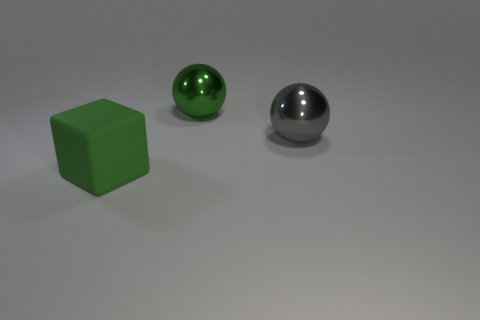There is a green object behind the green rubber object; does it have the same size as the green thing on the left side of the green sphere?
Give a very brief answer. Yes. What number of yellow things are either large balls or small shiny things?
Your response must be concise. 0. What is the size of the other object that is the same color as the big rubber thing?
Your answer should be very brief. Large. Are there more green cubes than big blue matte objects?
Provide a succinct answer. Yes. What number of objects are either big cyan matte cylinders or large green objects that are behind the big gray metal thing?
Make the answer very short. 1. What number of other objects are the same shape as the big green matte thing?
Give a very brief answer. 0. Are there fewer big gray things in front of the big green rubber object than green metallic spheres that are to the right of the big green ball?
Provide a short and direct response. No. Are there any other things that have the same material as the big green ball?
Your answer should be very brief. Yes. What shape is the large green thing that is made of the same material as the gray sphere?
Make the answer very short. Sphere. Is there any other thing of the same color as the big rubber object?
Ensure brevity in your answer.  Yes. 